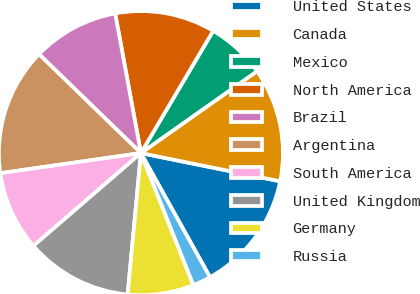<chart> <loc_0><loc_0><loc_500><loc_500><pie_chart><fcel>United States<fcel>Canada<fcel>Mexico<fcel>North America<fcel>Brazil<fcel>Argentina<fcel>South America<fcel>United Kingdom<fcel>Germany<fcel>Russia<nl><fcel>13.74%<fcel>12.96%<fcel>6.73%<fcel>11.4%<fcel>9.84%<fcel>14.52%<fcel>9.07%<fcel>12.18%<fcel>7.51%<fcel>2.06%<nl></chart> 